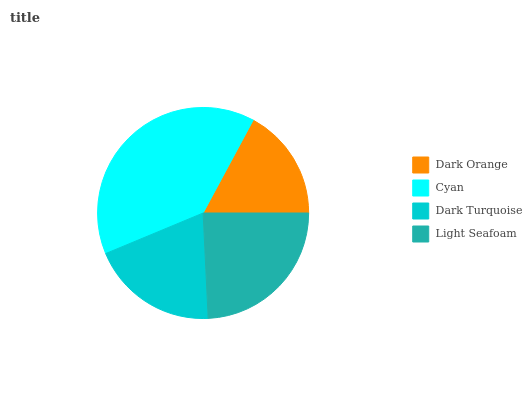Is Dark Orange the minimum?
Answer yes or no. Yes. Is Cyan the maximum?
Answer yes or no. Yes. Is Dark Turquoise the minimum?
Answer yes or no. No. Is Dark Turquoise the maximum?
Answer yes or no. No. Is Cyan greater than Dark Turquoise?
Answer yes or no. Yes. Is Dark Turquoise less than Cyan?
Answer yes or no. Yes. Is Dark Turquoise greater than Cyan?
Answer yes or no. No. Is Cyan less than Dark Turquoise?
Answer yes or no. No. Is Light Seafoam the high median?
Answer yes or no. Yes. Is Dark Turquoise the low median?
Answer yes or no. Yes. Is Cyan the high median?
Answer yes or no. No. Is Dark Orange the low median?
Answer yes or no. No. 